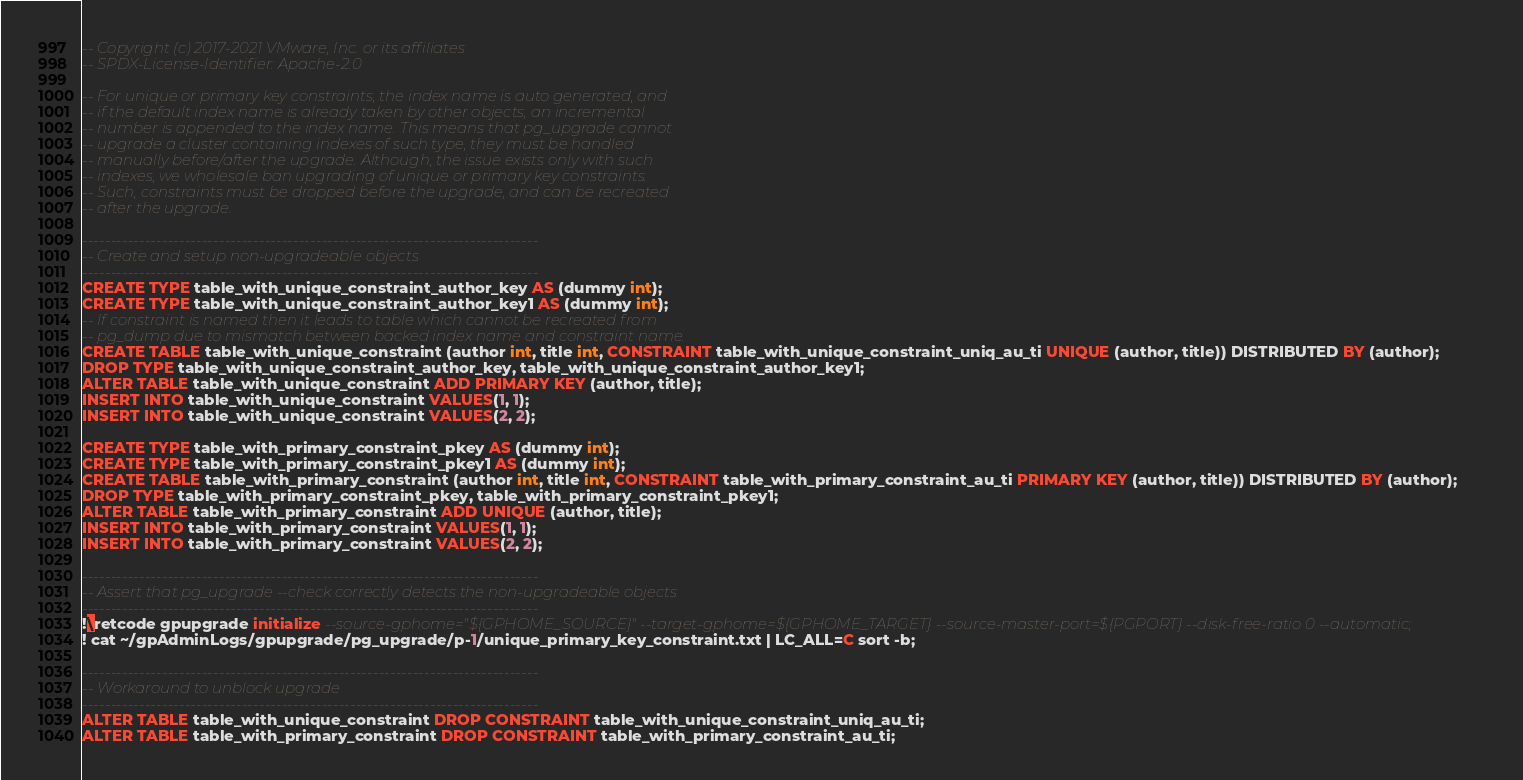<code> <loc_0><loc_0><loc_500><loc_500><_SQL_>-- Copyright (c) 2017-2021 VMware, Inc. or its affiliates
-- SPDX-License-Identifier: Apache-2.0

-- For unique or primary key constraints, the index name is auto generated, and
-- if the default index name is already taken by other objects, an incremental
-- number is appended to the index name. This means that pg_upgrade cannot
-- upgrade a cluster containing indexes of such type, they must be handled
-- manually before/after the upgrade. Although, the issue exists only with such
-- indexes, we wholesale ban upgrading of unique or primary key constraints.
-- Such, constraints must be dropped before the upgrade, and can be recreated
-- after the upgrade.

--------------------------------------------------------------------------------
-- Create and setup non-upgradeable objects
--------------------------------------------------------------------------------
CREATE TYPE table_with_unique_constraint_author_key AS (dummy int);
CREATE TYPE table_with_unique_constraint_author_key1 AS (dummy int);
-- If constraint is named then it leads to table which cannot be recreated from
-- pg_dump due to mismatch between backed index name and constraint name.
CREATE TABLE table_with_unique_constraint (author int, title int, CONSTRAINT table_with_unique_constraint_uniq_au_ti UNIQUE (author, title)) DISTRIBUTED BY (author);
DROP TYPE table_with_unique_constraint_author_key, table_with_unique_constraint_author_key1;
ALTER TABLE table_with_unique_constraint ADD PRIMARY KEY (author, title);
INSERT INTO table_with_unique_constraint VALUES(1, 1);
INSERT INTO table_with_unique_constraint VALUES(2, 2);

CREATE TYPE table_with_primary_constraint_pkey AS (dummy int);
CREATE TYPE table_with_primary_constraint_pkey1 AS (dummy int);
CREATE TABLE table_with_primary_constraint (author int, title int, CONSTRAINT table_with_primary_constraint_au_ti PRIMARY KEY (author, title)) DISTRIBUTED BY (author);
DROP TYPE table_with_primary_constraint_pkey, table_with_primary_constraint_pkey1;
ALTER TABLE table_with_primary_constraint ADD UNIQUE (author, title);
INSERT INTO table_with_primary_constraint VALUES(1, 1);
INSERT INTO table_with_primary_constraint VALUES(2, 2);

--------------------------------------------------------------------------------
-- Assert that pg_upgrade --check correctly detects the non-upgradeable objects
--------------------------------------------------------------------------------
!\retcode gpupgrade initialize --source-gphome="${GPHOME_SOURCE}" --target-gphome=${GPHOME_TARGET} --source-master-port=${PGPORT} --disk-free-ratio 0 --automatic;
! cat ~/gpAdminLogs/gpupgrade/pg_upgrade/p-1/unique_primary_key_constraint.txt | LC_ALL=C sort -b;

--------------------------------------------------------------------------------
-- Workaround to unblock upgrade
--------------------------------------------------------------------------------
ALTER TABLE table_with_unique_constraint DROP CONSTRAINT table_with_unique_constraint_uniq_au_ti;
ALTER TABLE table_with_primary_constraint DROP CONSTRAINT table_with_primary_constraint_au_ti;
</code> 